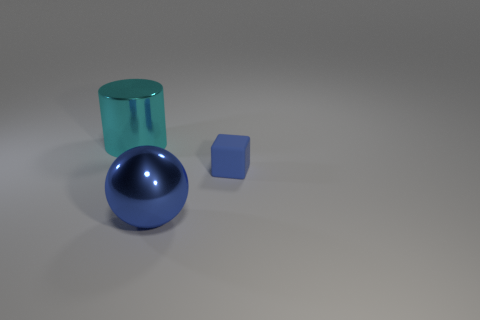There is a thing that is both behind the metallic ball and on the right side of the cyan cylinder; what is its shape?
Provide a short and direct response. Cube. Is there a small blue block that has the same material as the cyan cylinder?
Make the answer very short. No. What is the size of the cube that is the same color as the sphere?
Offer a terse response. Small. There is a thing in front of the rubber thing; what color is it?
Keep it short and to the point. Blue. There is a cyan thing; does it have the same shape as the large object that is right of the metallic cylinder?
Provide a succinct answer. No. Is there a shiny cylinder that has the same color as the big ball?
Make the answer very short. No. What is the size of the cylinder that is made of the same material as the blue sphere?
Provide a succinct answer. Large. Is the color of the shiny ball the same as the metal cylinder?
Ensure brevity in your answer.  No. There is a large object that is on the right side of the shiny cylinder; is its shape the same as the cyan object?
Keep it short and to the point. No. What number of cyan cylinders are the same size as the blue metal sphere?
Keep it short and to the point. 1. 